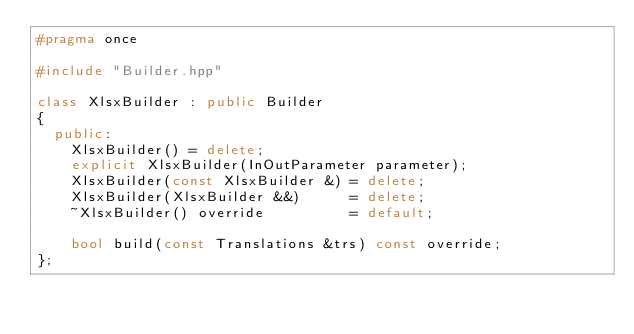<code> <loc_0><loc_0><loc_500><loc_500><_C++_>#pragma once

#include "Builder.hpp"

class XlsxBuilder : public Builder
{
  public:
    XlsxBuilder() = delete;
    explicit XlsxBuilder(InOutParameter parameter);
    XlsxBuilder(const XlsxBuilder &) = delete;
    XlsxBuilder(XlsxBuilder &&)      = delete;
    ~XlsxBuilder() override          = default;

    bool build(const Translations &trs) const override;
};
</code> 